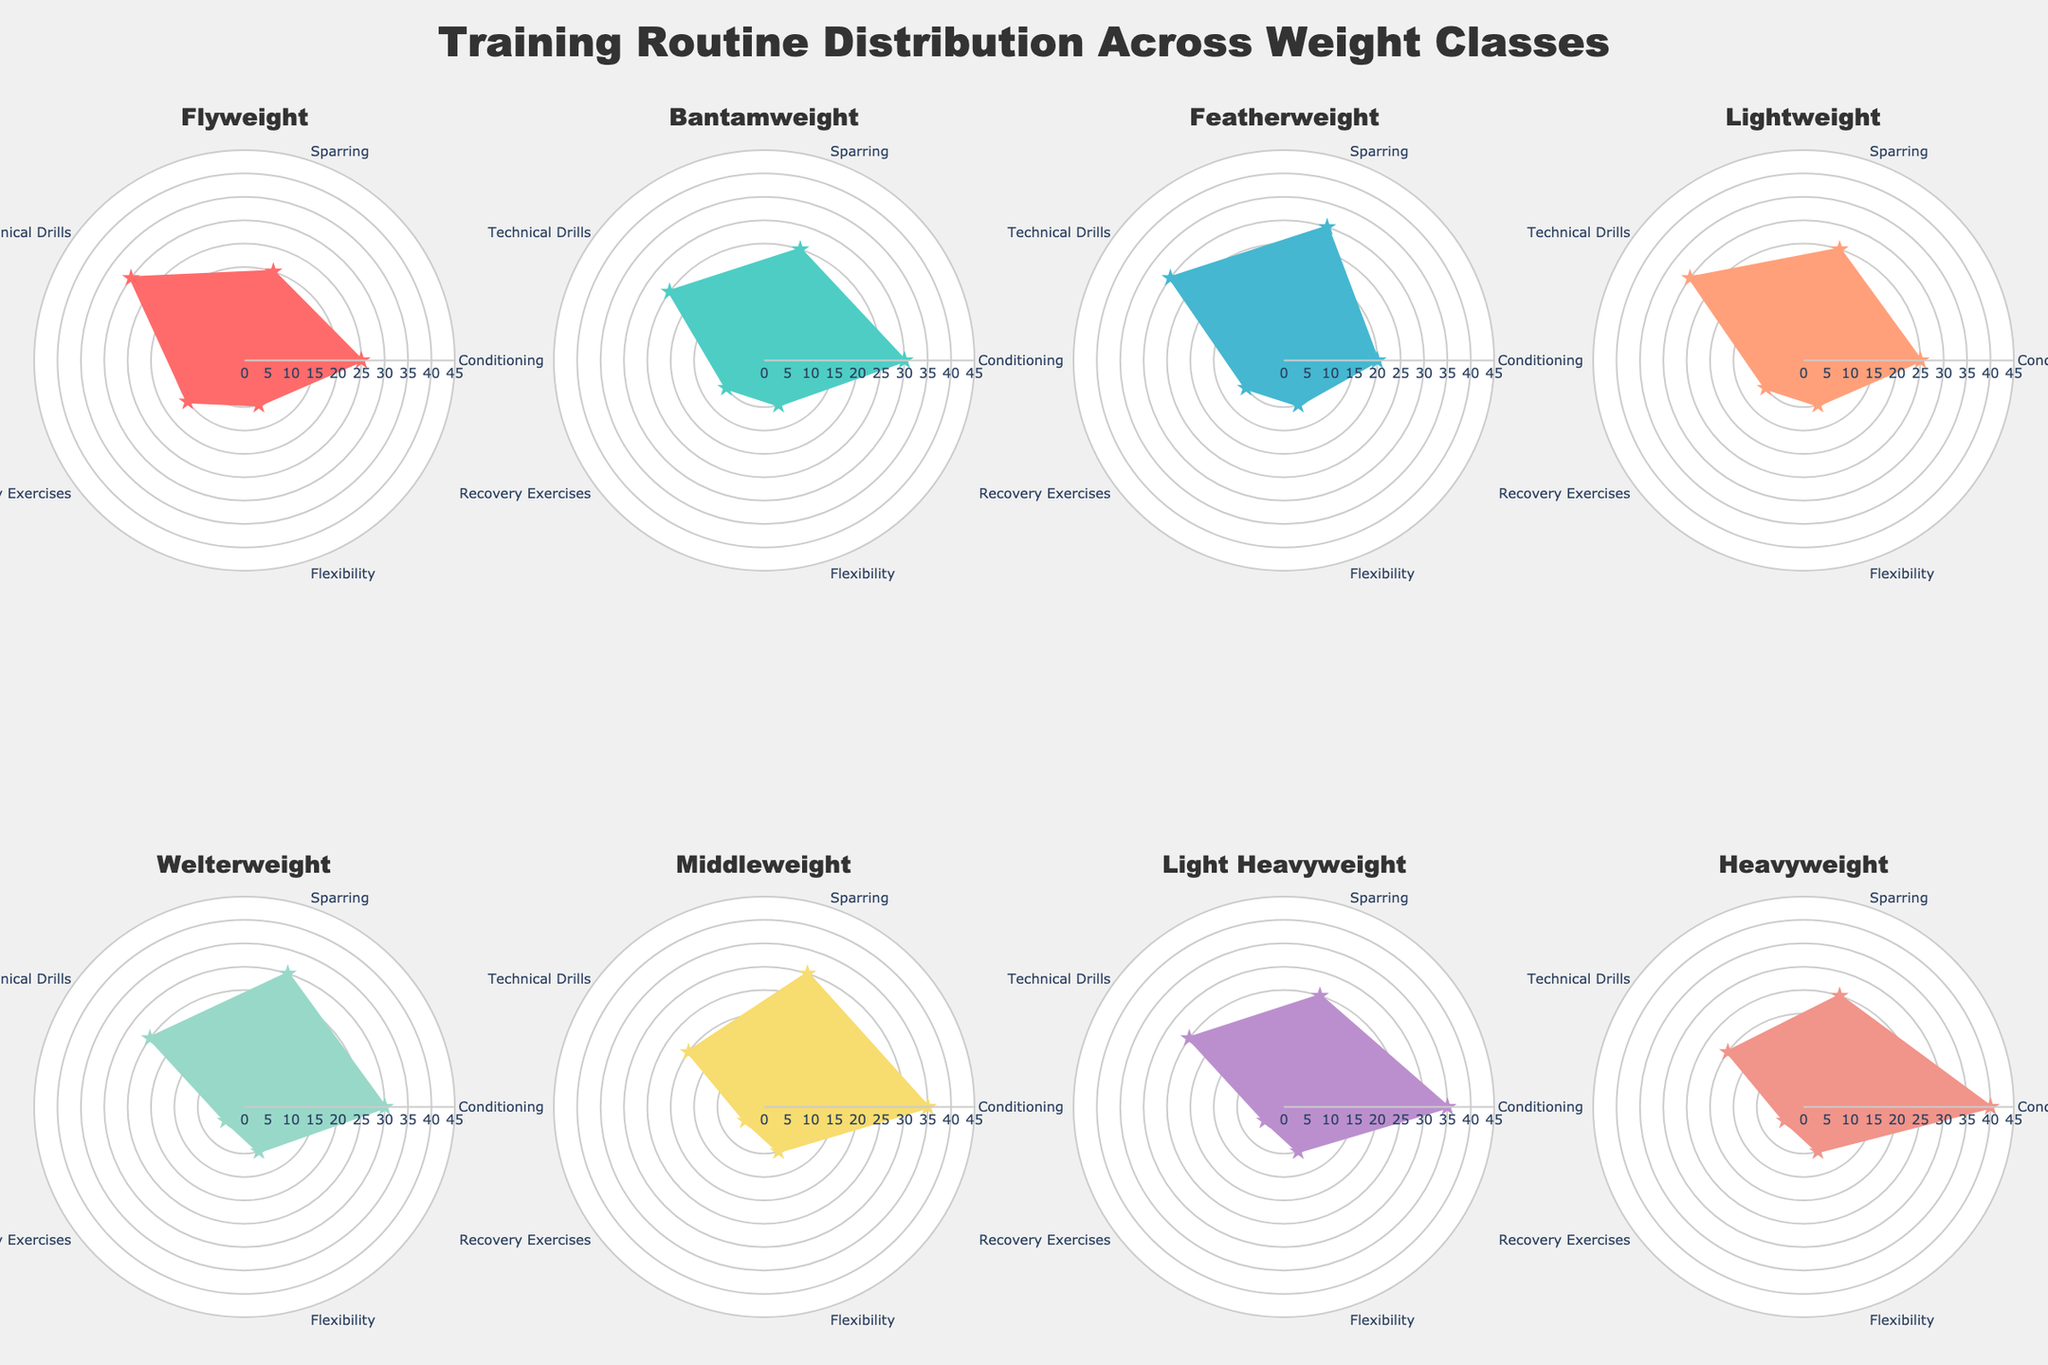What is the title of the figure? The title is located at the top center of the figure and it clearly states the purpose of the visualization.
Answer: "Training Routine Distribution Across Weight Classes" Which weight class dedicates the highest percentage to conditioning exercises? By examining the various radar charts, it's evident that the Heavyweight class has the highest value in the Conditioning section.
Answer: Heavyweight What are the common categories shown in each radar chart? Each subplot has labels that encompass the same set of categories, which are mentioned in the data.
Answer: Conditioning, Sparring, Technical Drills, Recovery Exercises, Flexibility What is the percentage range used for the radial axis of each radar chart? Observing the axis labels of any radar chart shows that the range starts from 0 and goes up to 45.
Answer: 0 to 45 Which weight class has the least focus on recovery exercises? By comparing the recovery exercises segment in each radar chart, the Welterweight, Middleweight, Light Heavyweight, and Heavyweight classes all have the lowest values.
Answer: Welterweight, Middleweight, Light Heavyweight, Heavyweight How does the percentage of technical drills differ between Flyweight and Middleweight classes? Flyweight has 30% for Technical Drills, while Middleweight has 20%, indicating a decrease of 10 percentage points.
Answer: 10% decrease Among Flyweight, Bantamweight, and Featherweight, which class dedicates the highest percentage to flexibility? Observing these classes, all three classes allocate an equal percentage, which is 10%, to Flexibility.
Answer: Equal, 10% What is the average percentage spent on sparring across all weight classes? Sum of sparring percentages: 20+25+30+25+30+30+25+25 = 210. There are 8 weight classes, so the average is 210/8.
Answer: 26.25% Is there a weight class that allocates more than 30% to any category other than Conditioning or Sparring? We look at each chart, beyond Conditioning and Sparring. Only Flyweight and Featherweight have 30% for Technical Drills.
Answer: Flyweight, Featherweight For Lightweight and Welterweight classes, which training category has no difference in their percentages? Both classes allocate 30% for Technical Drills, indicating no difference in this category.
Answer: Technical Drills 